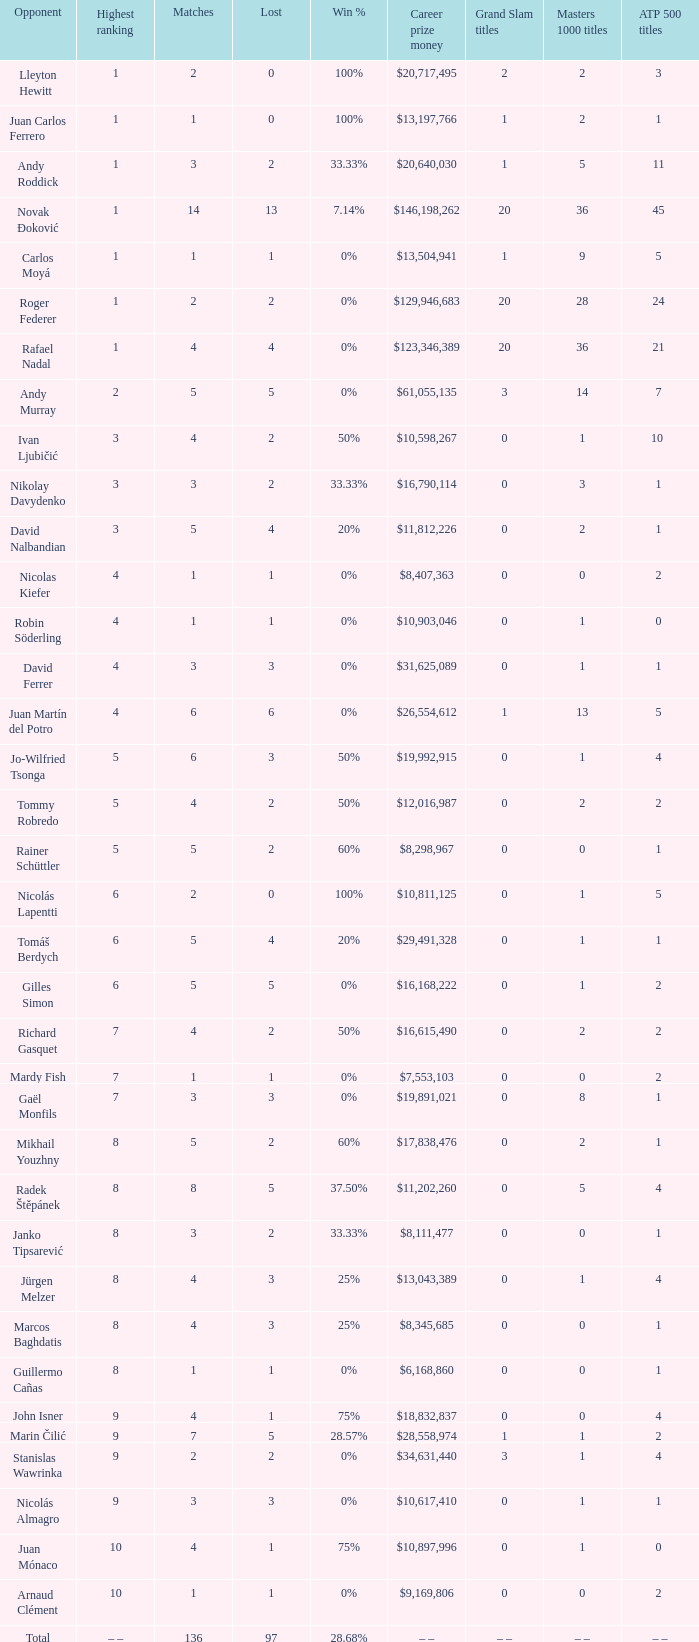What is the total number of Lost for the Highest Ranking of – –? 1.0. 